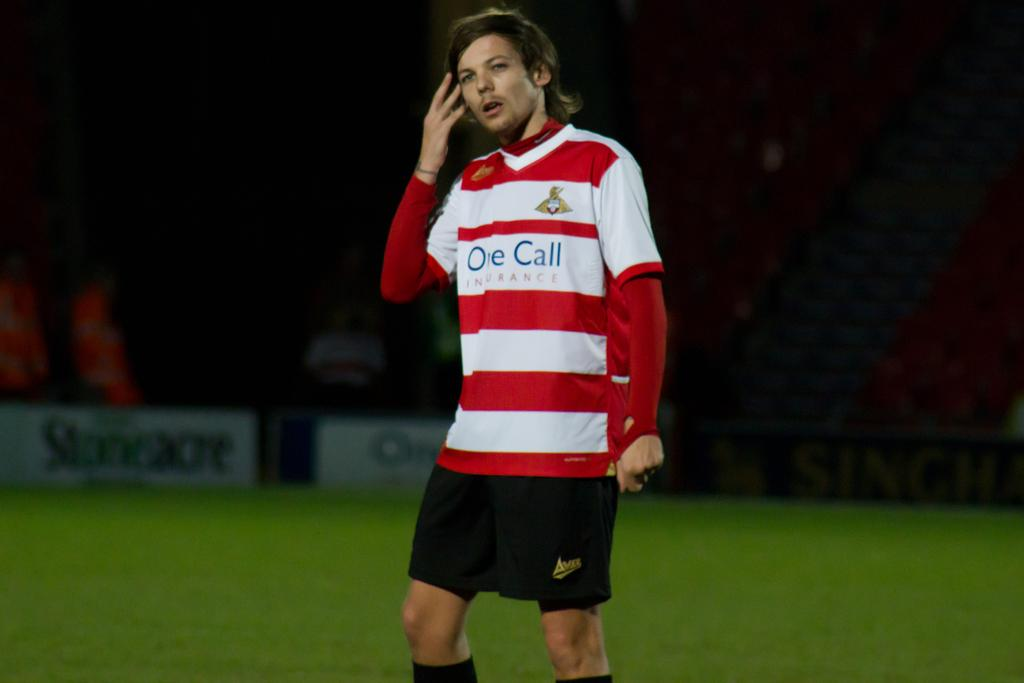<image>
Present a compact description of the photo's key features. A soccer player stands on the field with the words one call on his jersey 